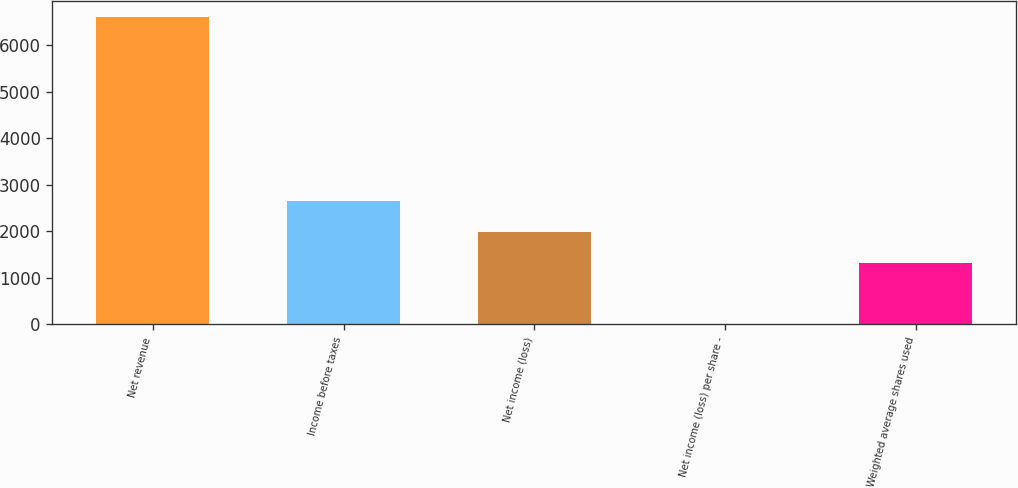Convert chart to OTSL. <chart><loc_0><loc_0><loc_500><loc_500><bar_chart><fcel>Net revenue<fcel>Income before taxes<fcel>Net income (loss)<fcel>Net income (loss) per share -<fcel>Weighted average shares used<nl><fcel>6615<fcel>2647.76<fcel>1986.55<fcel>2.92<fcel>1325.34<nl></chart> 